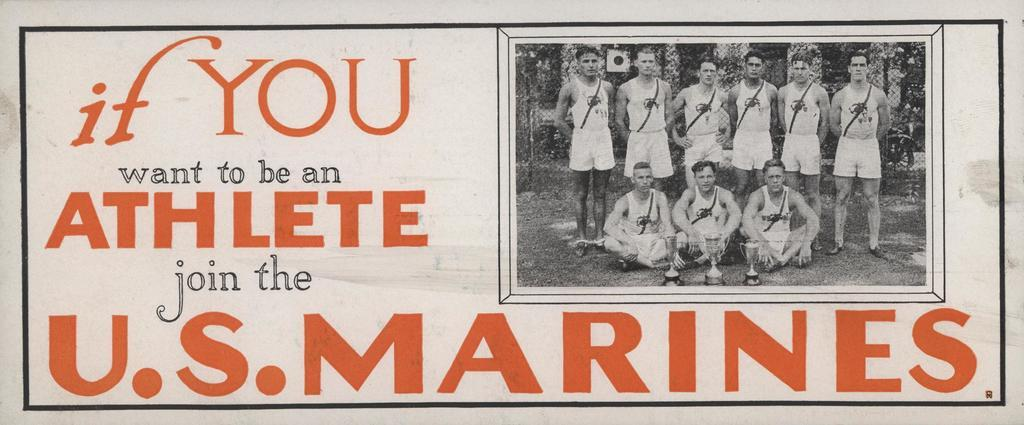<image>
Create a compact narrative representing the image presented. a poster reading If You want to be an athlete Join the US Marines 